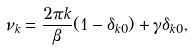Convert formula to latex. <formula><loc_0><loc_0><loc_500><loc_500>\nu _ { k } = \frac { 2 \pi k } { \beta } ( 1 - \delta _ { k 0 } ) + \gamma \delta _ { k 0 } ,</formula> 